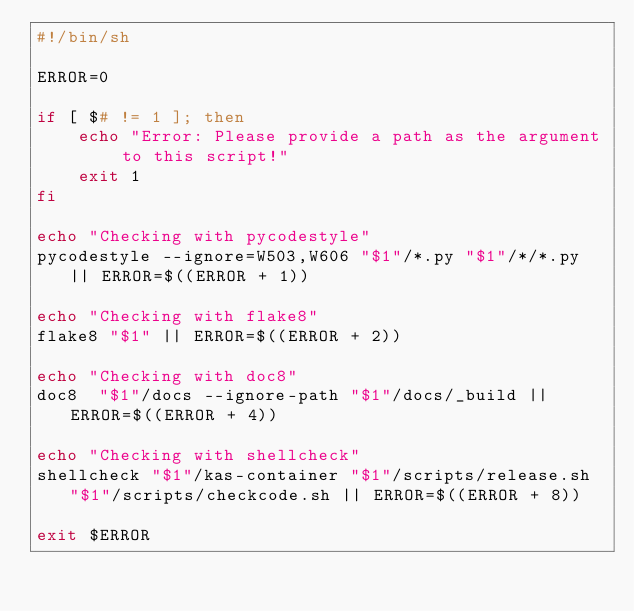<code> <loc_0><loc_0><loc_500><loc_500><_Bash_>#!/bin/sh

ERROR=0

if [ $# != 1 ]; then
    echo "Error: Please provide a path as the argument to this script!"
    exit 1
fi

echo "Checking with pycodestyle"
pycodestyle --ignore=W503,W606 "$1"/*.py "$1"/*/*.py || ERROR=$((ERROR + 1))

echo "Checking with flake8"
flake8 "$1" || ERROR=$((ERROR + 2))

echo "Checking with doc8"
doc8  "$1"/docs --ignore-path "$1"/docs/_build || ERROR=$((ERROR + 4))

echo "Checking with shellcheck"
shellcheck "$1"/kas-container "$1"/scripts/release.sh "$1"/scripts/checkcode.sh || ERROR=$((ERROR + 8))

exit $ERROR
</code> 